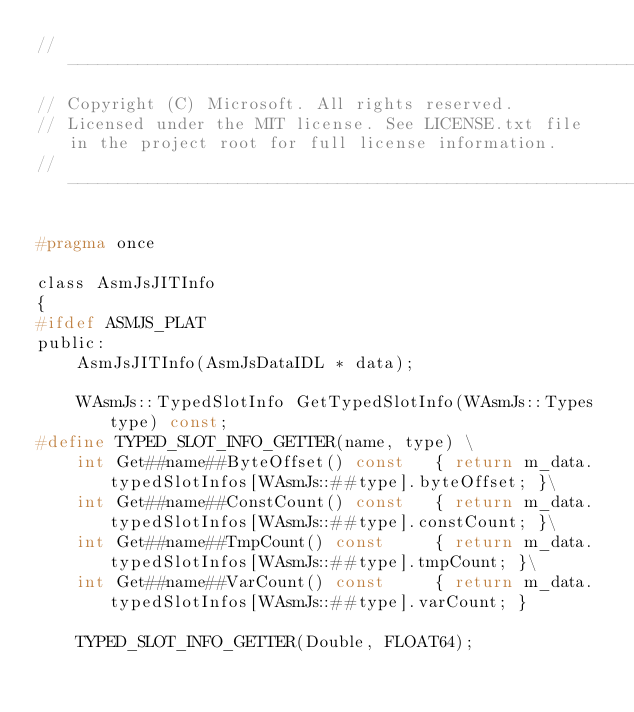<code> <loc_0><loc_0><loc_500><loc_500><_C_>//-------------------------------------------------------------------------------------------------------
// Copyright (C) Microsoft. All rights reserved.
// Licensed under the MIT license. See LICENSE.txt file in the project root for full license information.
//-------------------------------------------------------------------------------------------------------

#pragma once

class AsmJsJITInfo
{
#ifdef ASMJS_PLAT
public:
    AsmJsJITInfo(AsmJsDataIDL * data);

    WAsmJs::TypedSlotInfo GetTypedSlotInfo(WAsmJs::Types type) const;
#define TYPED_SLOT_INFO_GETTER(name, type) \
    int Get##name##ByteOffset() const   { return m_data.typedSlotInfos[WAsmJs::##type].byteOffset; }\
    int Get##name##ConstCount() const   { return m_data.typedSlotInfos[WAsmJs::##type].constCount; }\
    int Get##name##TmpCount() const     { return m_data.typedSlotInfos[WAsmJs::##type].tmpCount; }\
    int Get##name##VarCount() const     { return m_data.typedSlotInfos[WAsmJs::##type].varCount; }

    TYPED_SLOT_INFO_GETTER(Double, FLOAT64);</code> 